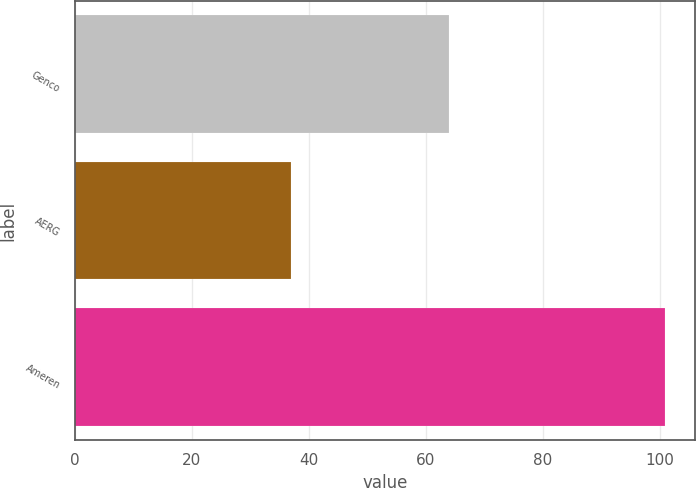<chart> <loc_0><loc_0><loc_500><loc_500><bar_chart><fcel>Genco<fcel>AERG<fcel>Ameren<nl><fcel>64<fcel>37<fcel>101<nl></chart> 